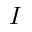Convert formula to latex. <formula><loc_0><loc_0><loc_500><loc_500>I</formula> 